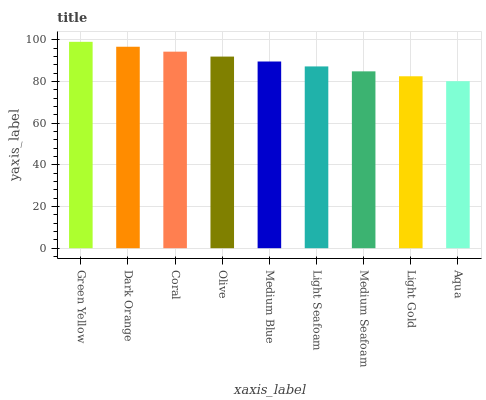Is Aqua the minimum?
Answer yes or no. Yes. Is Green Yellow the maximum?
Answer yes or no. Yes. Is Dark Orange the minimum?
Answer yes or no. No. Is Dark Orange the maximum?
Answer yes or no. No. Is Green Yellow greater than Dark Orange?
Answer yes or no. Yes. Is Dark Orange less than Green Yellow?
Answer yes or no. Yes. Is Dark Orange greater than Green Yellow?
Answer yes or no. No. Is Green Yellow less than Dark Orange?
Answer yes or no. No. Is Medium Blue the high median?
Answer yes or no. Yes. Is Medium Blue the low median?
Answer yes or no. Yes. Is Dark Orange the high median?
Answer yes or no. No. Is Dark Orange the low median?
Answer yes or no. No. 